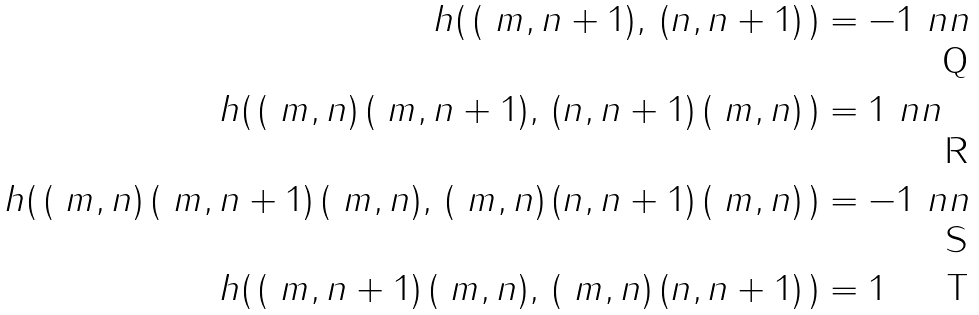Convert formula to latex. <formula><loc_0><loc_0><loc_500><loc_500>h ( \, ( \ m , n + 1 ) , \, ( n , n + 1 ) \, ) & = - 1 \ n n \\ h ( \, ( \ m , n ) \, ( \ m , n + 1 ) , \, ( n , n + 1 ) \, ( \ m , n ) \, ) & = 1 \ n n \\ h ( \, ( \ m , n ) \, ( \ m , n + 1 ) \, ( \ m , n ) , \, ( \ m , n ) \, ( n , n + 1 ) \, ( \ m , n ) \, ) & = - 1 \ n n \\ h ( \, ( \ m , n + 1 ) \, ( \ m , n ) , \, ( \ m , n ) \, ( n , n + 1 ) \, ) & = 1</formula> 